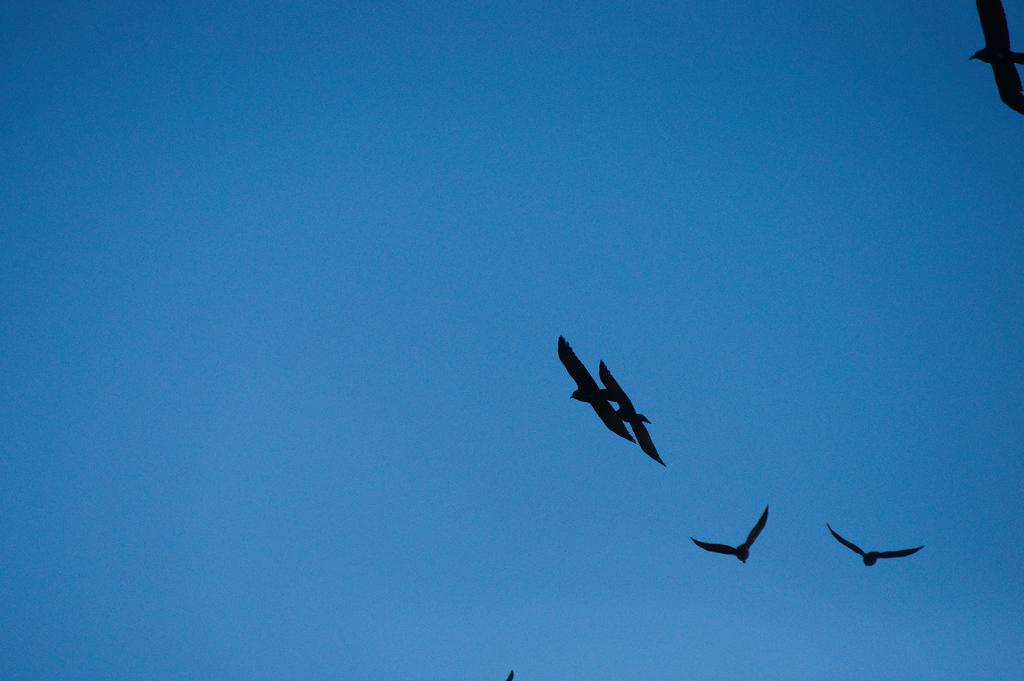What type of animals can be seen in the image? Birds can be seen in the image. What are the birds doing in the image? The birds are flying in the sky. What type of apple is being held by the hen in the image? There is no hen or apple present in the image; it features birds flying in the sky. What shape is the bird in the image? The question about the shape of the bird is not relevant, as the image does not focus on the shape of the birds, but rather their action of flying in the sky. 